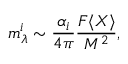<formula> <loc_0><loc_0><loc_500><loc_500>m _ { \lambda } ^ { i } \sim { \frac { \alpha _ { i } } { 4 \pi } } { \frac { F \langle X \rangle } { M ^ { 2 } } } ,</formula> 